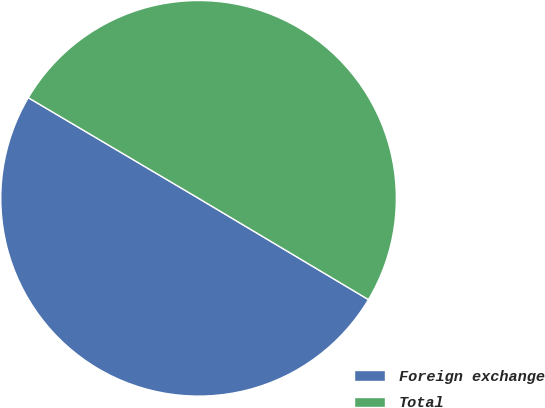Convert chart. <chart><loc_0><loc_0><loc_500><loc_500><pie_chart><fcel>Foreign exchange<fcel>Total<nl><fcel>49.94%<fcel>50.06%<nl></chart> 